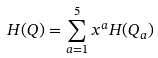Convert formula to latex. <formula><loc_0><loc_0><loc_500><loc_500>H ( Q ) = \sum _ { a = 1 } ^ { 5 } x ^ { a } H ( Q _ { a } )</formula> 